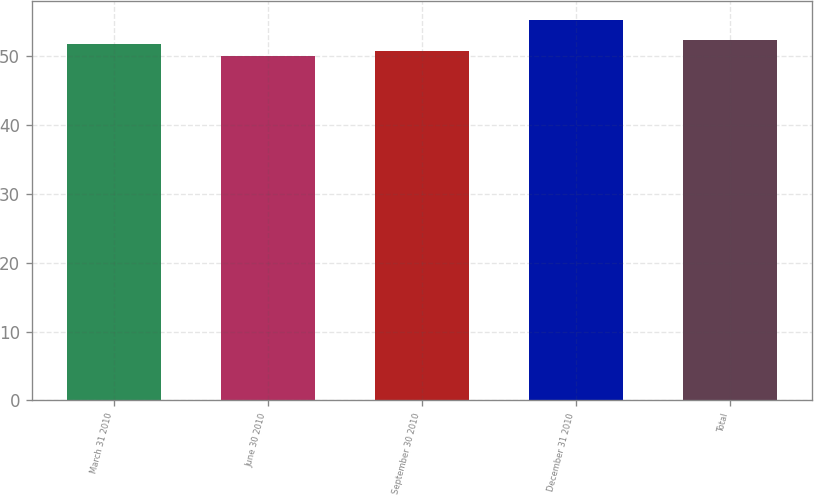<chart> <loc_0><loc_0><loc_500><loc_500><bar_chart><fcel>March 31 2010<fcel>June 30 2010<fcel>September 30 2010<fcel>December 31 2010<fcel>Total<nl><fcel>51.88<fcel>50.07<fcel>50.73<fcel>55.27<fcel>52.4<nl></chart> 